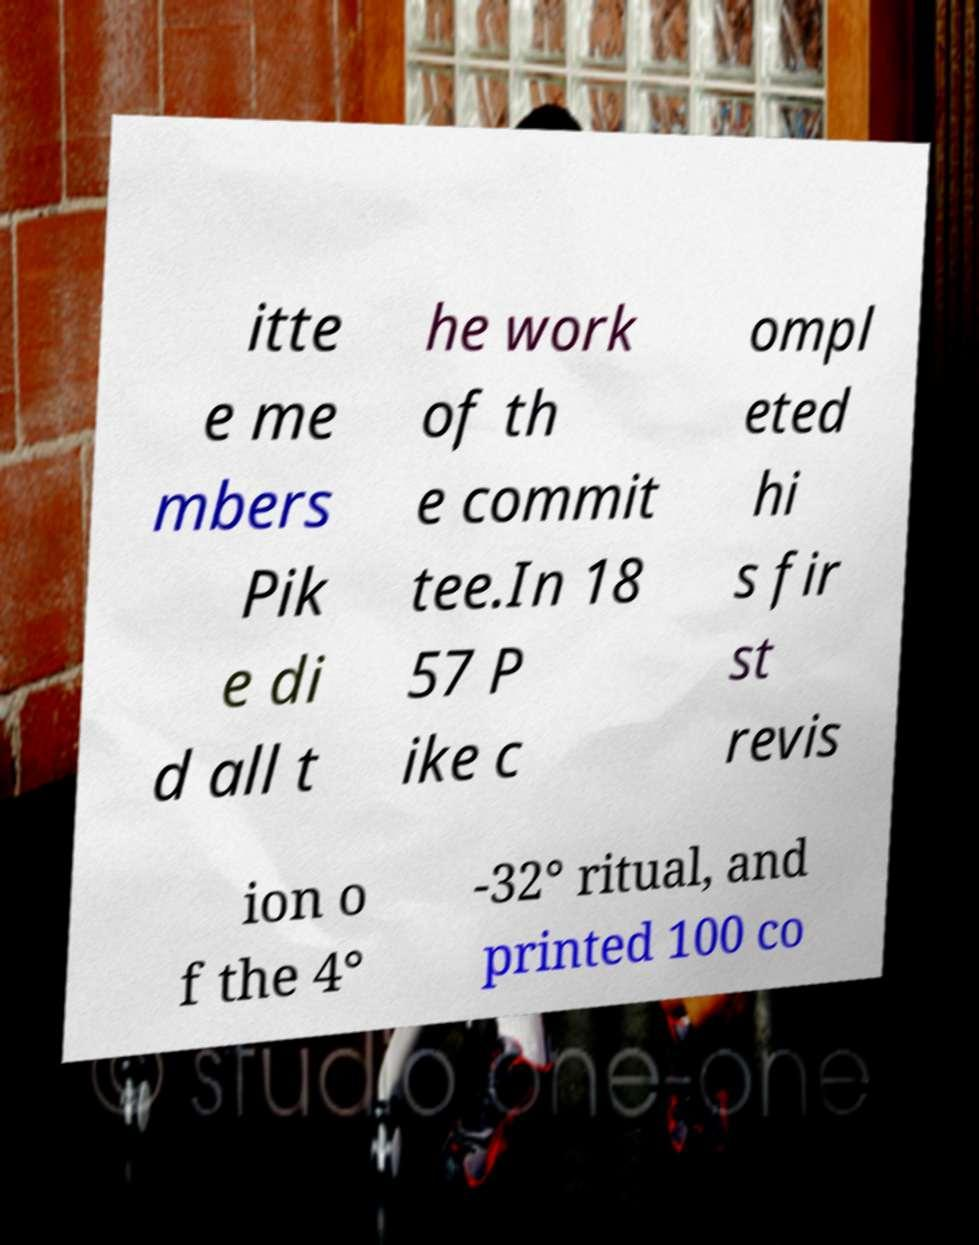I need the written content from this picture converted into text. Can you do that? itte e me mbers Pik e di d all t he work of th e commit tee.In 18 57 P ike c ompl eted hi s fir st revis ion o f the 4° -32° ritual, and printed 100 co 